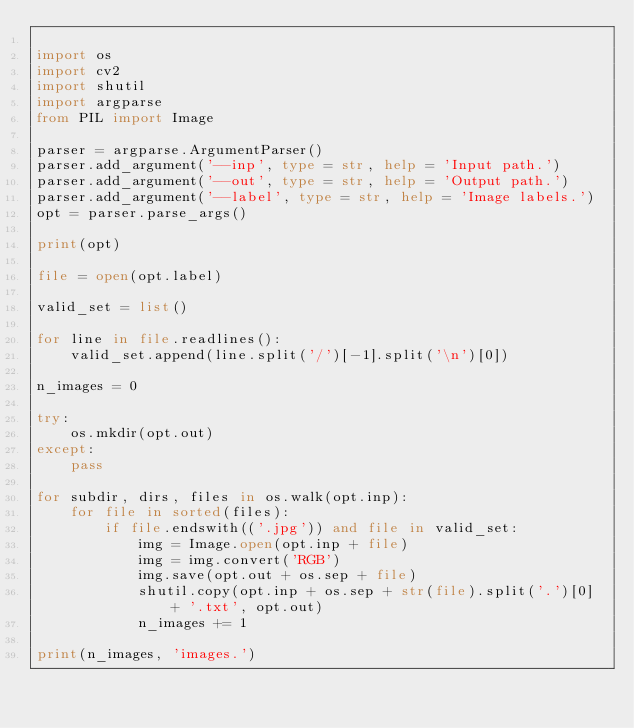Convert code to text. <code><loc_0><loc_0><loc_500><loc_500><_Python_>
import os
import cv2
import shutil
import argparse
from PIL import Image

parser = argparse.ArgumentParser()
parser.add_argument('--inp', type = str, help = 'Input path.')
parser.add_argument('--out', type = str, help = 'Output path.')
parser.add_argument('--label', type = str, help = 'Image labels.')
opt = parser.parse_args()

print(opt)

file = open(opt.label)

valid_set = list()

for line in file.readlines():
    valid_set.append(line.split('/')[-1].split('\n')[0])

n_images = 0

try:
    os.mkdir(opt.out)
except:
    pass

for subdir, dirs, files in os.walk(opt.inp):
    for file in sorted(files):
        if file.endswith(('.jpg')) and file in valid_set:
            img = Image.open(opt.inp + file)
            img = img.convert('RGB')
            img.save(opt.out + os.sep + file)
            shutil.copy(opt.inp + os.sep + str(file).split('.')[0] + '.txt', opt.out)
            n_images += 1

print(n_images, 'images.')</code> 